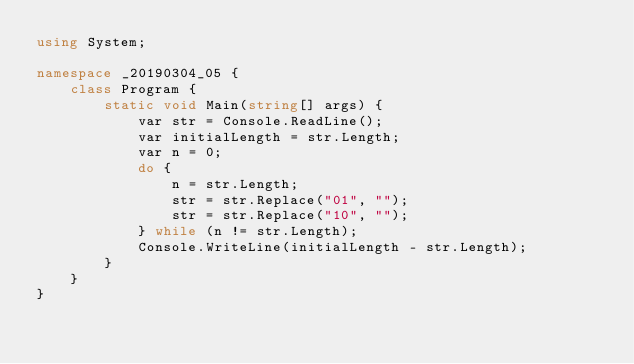Convert code to text. <code><loc_0><loc_0><loc_500><loc_500><_C#_>using System;

namespace _20190304_05 {
    class Program {
        static void Main(string[] args) {
            var str = Console.ReadLine();
            var initialLength = str.Length;
            var n = 0;
            do {
                n = str.Length;
                str = str.Replace("01", "");
                str = str.Replace("10", "");
            } while (n != str.Length);
            Console.WriteLine(initialLength - str.Length);
        }
    }
}
</code> 